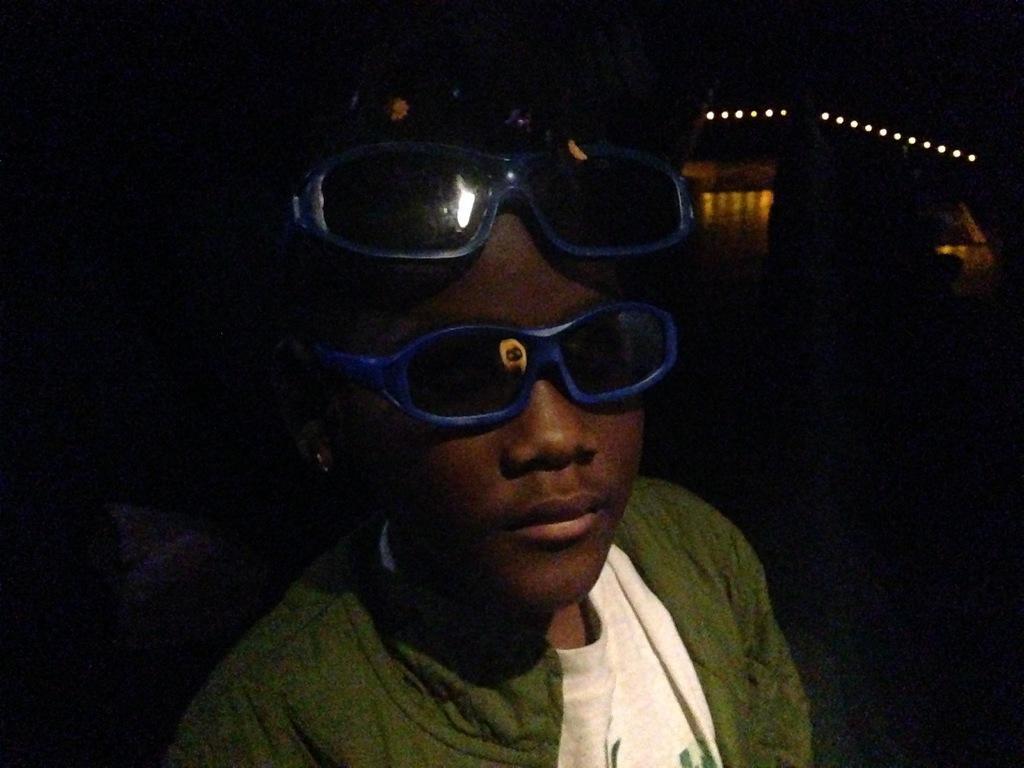Can you describe this image briefly? In this picture we can see a person, goggles, lights and some objects and in the background it is dark. 